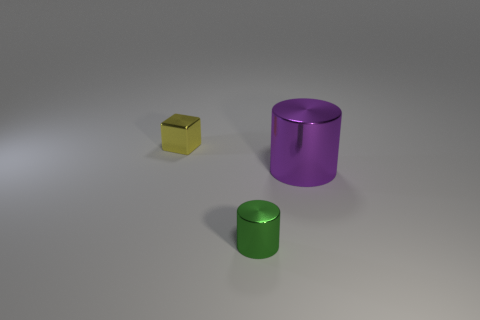Add 1 tiny blue cylinders. How many objects exist? 4 Subtract all cylinders. How many objects are left? 1 Subtract 0 green cubes. How many objects are left? 3 Subtract all tiny cylinders. Subtract all metal cubes. How many objects are left? 1 Add 2 tiny green shiny cylinders. How many tiny green shiny cylinders are left? 3 Add 1 small rubber objects. How many small rubber objects exist? 1 